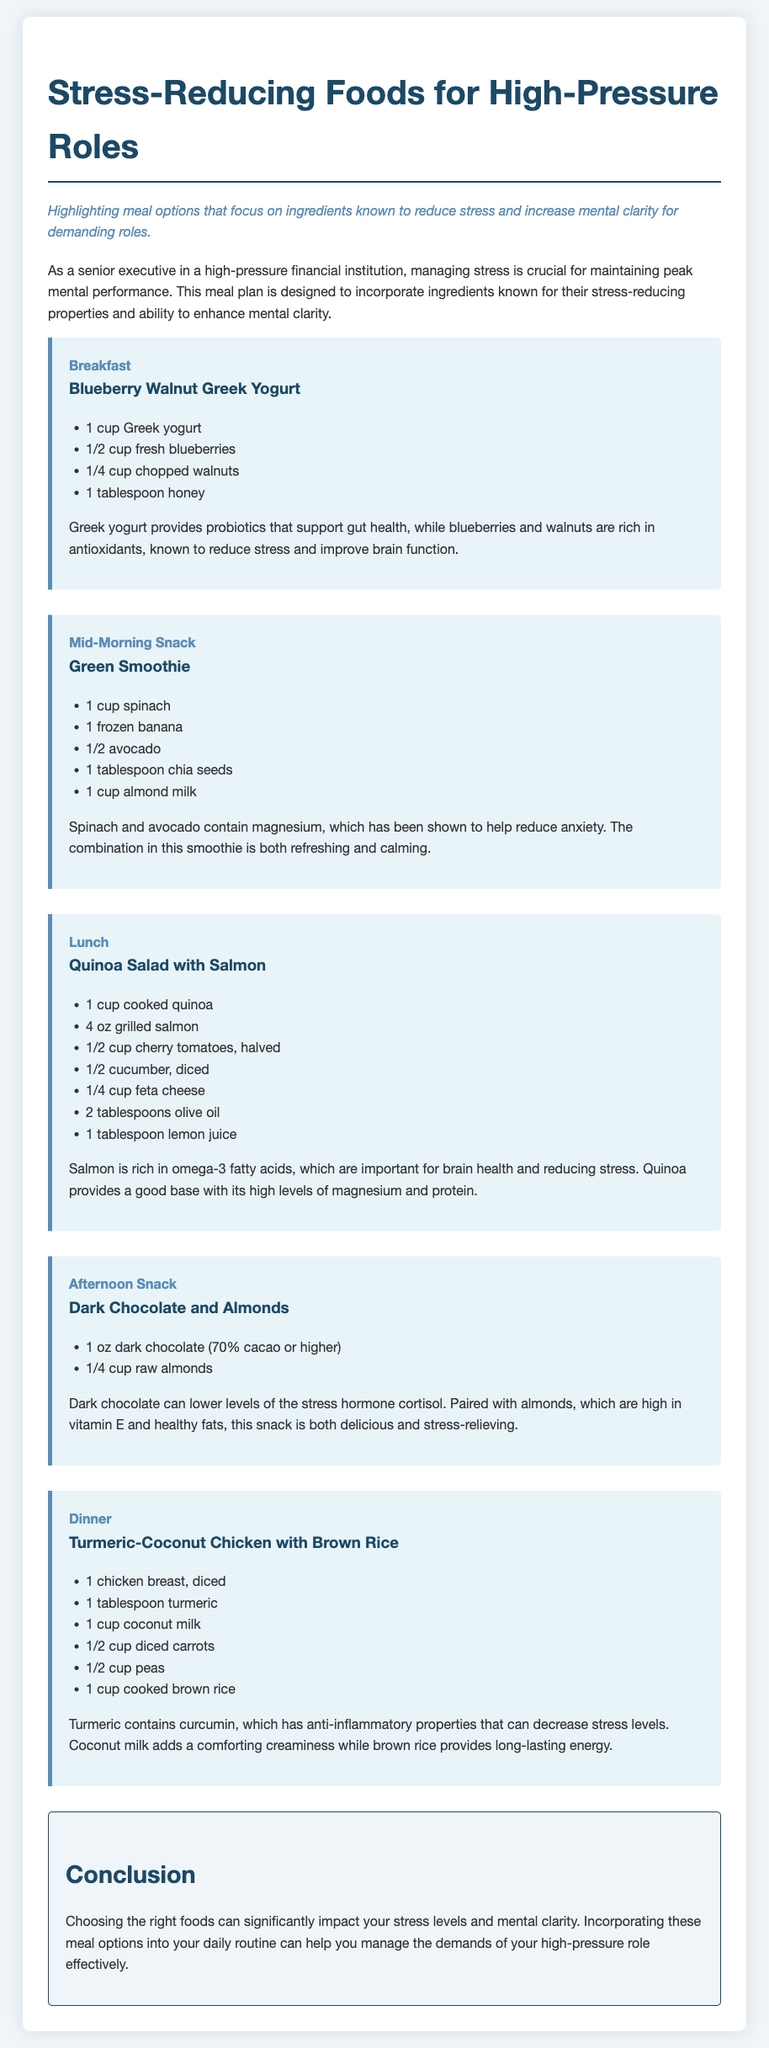What are the main ingredients in the Breakfast meal? The Breakfast meal features Greek yogurt, blueberries, walnuts, and honey as its main ingredients.
Answer: Greek yogurt, blueberries, walnuts, honey How does the Green Smoothie help reduce anxiety? The Green Smoothie includes spinach and avocado, both of which contain magnesium that helps reduce anxiety.
Answer: Magnesium What is the protein source in the Lunch meal? The Lunch meal includes grilled salmon as the protein source.
Answer: Grilled salmon Which snack contains dark chocolate? The Afternoon Snack includes dark chocolate paired with almonds.
Answer: Dark Chocolate and Almonds What is the cooking method for the chicken in Dinner? The chicken in the Dinner meal is diced and cooked with turmeric and coconut milk.
Answer: Diced How many ounces of dark chocolate should be consumed as a snack? The document specifies an amount of 1 ounce of dark chocolate for the snack.
Answer: 1 ounce What type of rice is used in the Dinner meal? The Dinner meal uses brown rice as its carbohydrate component.
Answer: Brown rice Which meal features quinoa as an ingredient? The Lunch meal includes cooked quinoa as one of its ingredients.
Answer: Lunch What role does turmeric play in the Dinner meal? Turmeric contains curcumin, known for its anti-inflammatory properties that can decrease stress levels.
Answer: Anti-inflammatory 